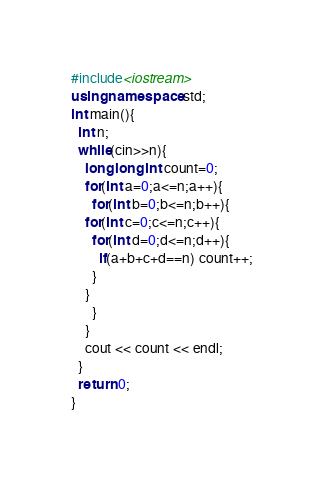<code> <loc_0><loc_0><loc_500><loc_500><_C++_>#include<iostream>
using namespace std;
int main(){
  int n;
  while(cin>>n){
    long long int count=0;
    for(int a=0;a<=n;a++){
      for(int b=0;b<=n;b++){
	for(int c=0;c<=n;c++){
	  for(int d=0;d<=n;d++){
	    if(a+b+c+d==n) count++;
	  }
	}
      }
    }
    cout << count << endl;
  }
  return 0;
}</code> 